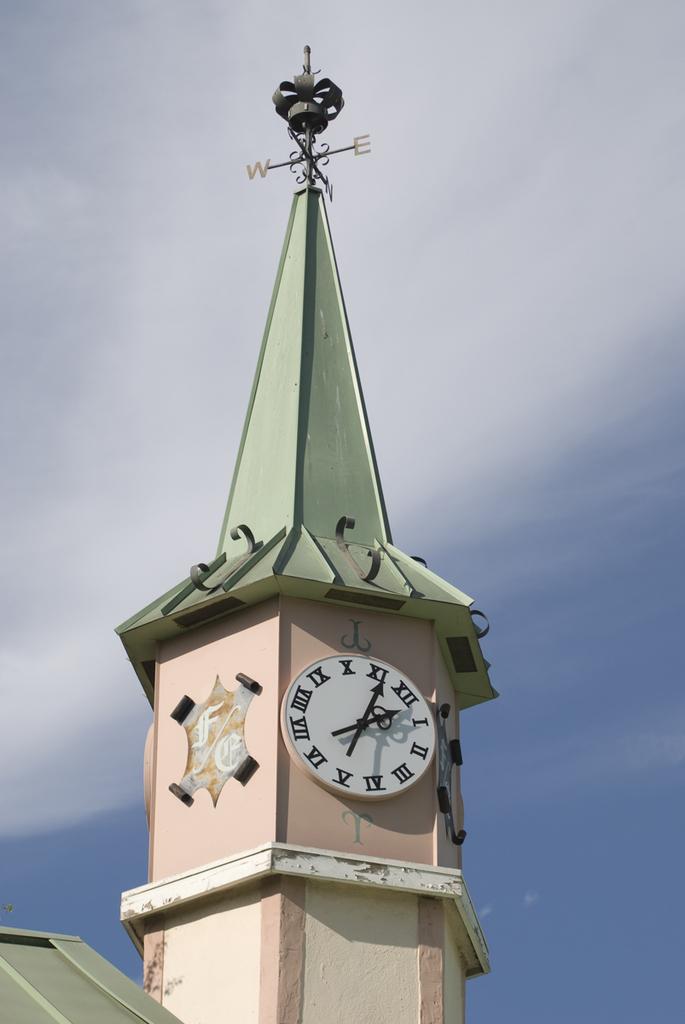What time is shown on the clock?
Keep it short and to the point. 12:56. What letters are visible on the top wind compass?
Provide a short and direct response. We. 